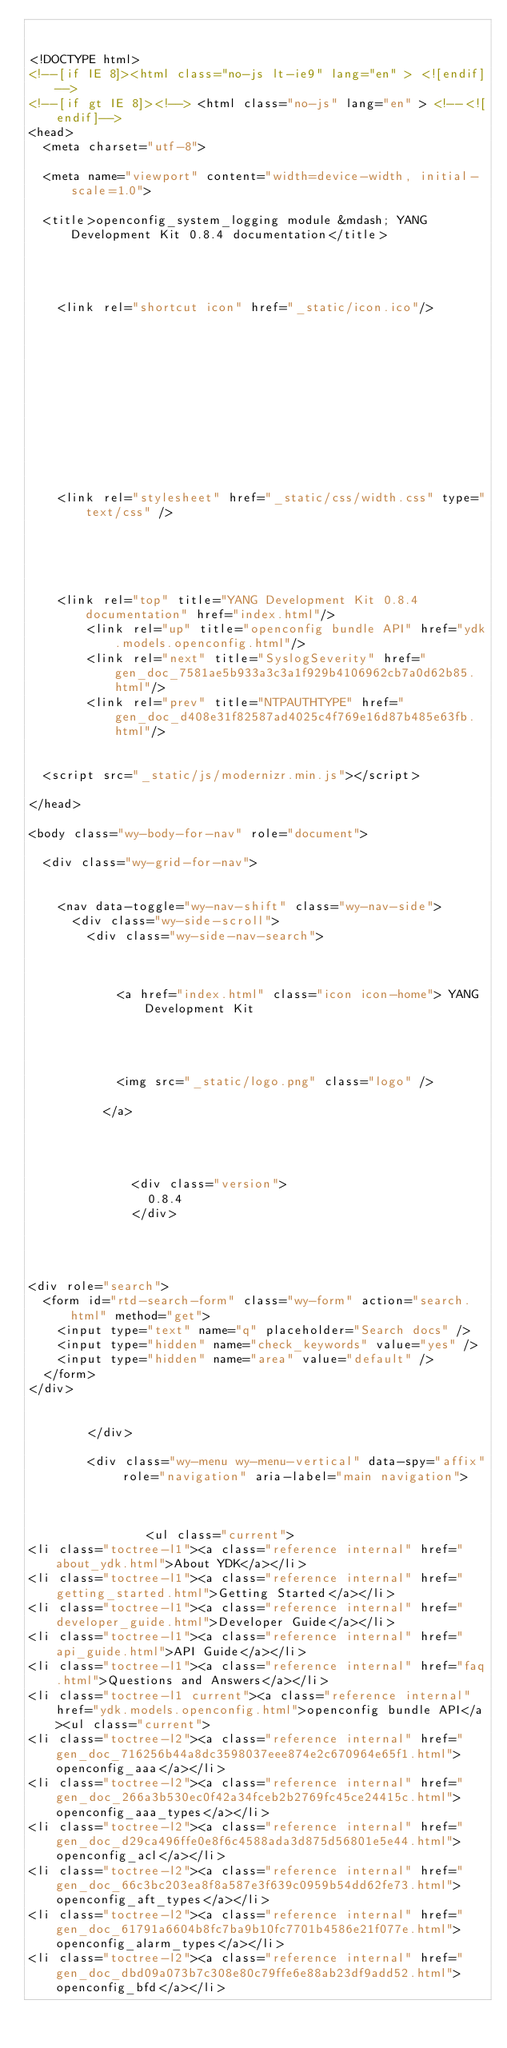Convert code to text. <code><loc_0><loc_0><loc_500><loc_500><_HTML_>

<!DOCTYPE html>
<!--[if IE 8]><html class="no-js lt-ie9" lang="en" > <![endif]-->
<!--[if gt IE 8]><!--> <html class="no-js" lang="en" > <!--<![endif]-->
<head>
  <meta charset="utf-8">
  
  <meta name="viewport" content="width=device-width, initial-scale=1.0">
  
  <title>openconfig_system_logging module &mdash; YANG Development Kit 0.8.4 documentation</title>
  

  
  
    <link rel="shortcut icon" href="_static/icon.ico"/>
  

  

  
  
    

  

  
  
    <link rel="stylesheet" href="_static/css/width.css" type="text/css" />
  

  

  
    <link rel="top" title="YANG Development Kit 0.8.4 documentation" href="index.html"/>
        <link rel="up" title="openconfig bundle API" href="ydk.models.openconfig.html"/>
        <link rel="next" title="SyslogSeverity" href="gen_doc_7581ae5b933a3c3a1f929b4106962cb7a0d62b85.html"/>
        <link rel="prev" title="NTPAUTHTYPE" href="gen_doc_d408e31f82587ad4025c4f769e16d87b485e63fb.html"/> 

  
  <script src="_static/js/modernizr.min.js"></script>

</head>

<body class="wy-body-for-nav" role="document">

  <div class="wy-grid-for-nav">

    
    <nav data-toggle="wy-nav-shift" class="wy-nav-side">
      <div class="wy-side-scroll">
        <div class="wy-side-nav-search">
          

          
            <a href="index.html" class="icon icon-home"> YANG Development Kit
          

          
            
            <img src="_static/logo.png" class="logo" />
          
          </a>

          
            
            
              <div class="version">
                0.8.4
              </div>
            
          

          
<div role="search">
  <form id="rtd-search-form" class="wy-form" action="search.html" method="get">
    <input type="text" name="q" placeholder="Search docs" />
    <input type="hidden" name="check_keywords" value="yes" />
    <input type="hidden" name="area" value="default" />
  </form>
</div>

          
        </div>

        <div class="wy-menu wy-menu-vertical" data-spy="affix" role="navigation" aria-label="main navigation">
          
            
            
                <ul class="current">
<li class="toctree-l1"><a class="reference internal" href="about_ydk.html">About YDK</a></li>
<li class="toctree-l1"><a class="reference internal" href="getting_started.html">Getting Started</a></li>
<li class="toctree-l1"><a class="reference internal" href="developer_guide.html">Developer Guide</a></li>
<li class="toctree-l1"><a class="reference internal" href="api_guide.html">API Guide</a></li>
<li class="toctree-l1"><a class="reference internal" href="faq.html">Questions and Answers</a></li>
<li class="toctree-l1 current"><a class="reference internal" href="ydk.models.openconfig.html">openconfig bundle API</a><ul class="current">
<li class="toctree-l2"><a class="reference internal" href="gen_doc_716256b44a8dc3598037eee874e2c670964e65f1.html">openconfig_aaa</a></li>
<li class="toctree-l2"><a class="reference internal" href="gen_doc_266a3b530ec0f42a34fceb2b2769fc45ce24415c.html">openconfig_aaa_types</a></li>
<li class="toctree-l2"><a class="reference internal" href="gen_doc_d29ca496ffe0e8f6c4588ada3d875d56801e5e44.html">openconfig_acl</a></li>
<li class="toctree-l2"><a class="reference internal" href="gen_doc_66c3bc203ea8f8a587e3f639c0959b54dd62fe73.html">openconfig_aft_types</a></li>
<li class="toctree-l2"><a class="reference internal" href="gen_doc_61791a6604b8fc7ba9b10fc7701b4586e21f077e.html">openconfig_alarm_types</a></li>
<li class="toctree-l2"><a class="reference internal" href="gen_doc_dbd09a073b7c308e80c79ffe6e88ab23df9add52.html">openconfig_bfd</a></li></code> 